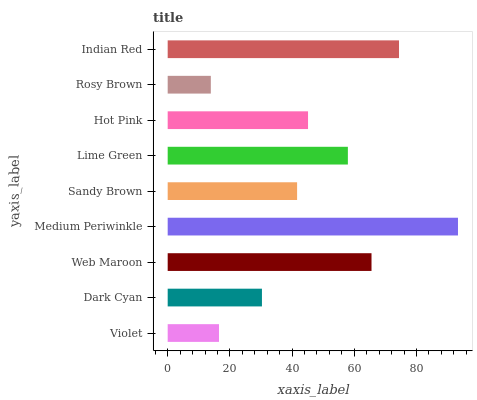Is Rosy Brown the minimum?
Answer yes or no. Yes. Is Medium Periwinkle the maximum?
Answer yes or no. Yes. Is Dark Cyan the minimum?
Answer yes or no. No. Is Dark Cyan the maximum?
Answer yes or no. No. Is Dark Cyan greater than Violet?
Answer yes or no. Yes. Is Violet less than Dark Cyan?
Answer yes or no. Yes. Is Violet greater than Dark Cyan?
Answer yes or no. No. Is Dark Cyan less than Violet?
Answer yes or no. No. Is Hot Pink the high median?
Answer yes or no. Yes. Is Hot Pink the low median?
Answer yes or no. Yes. Is Lime Green the high median?
Answer yes or no. No. Is Violet the low median?
Answer yes or no. No. 